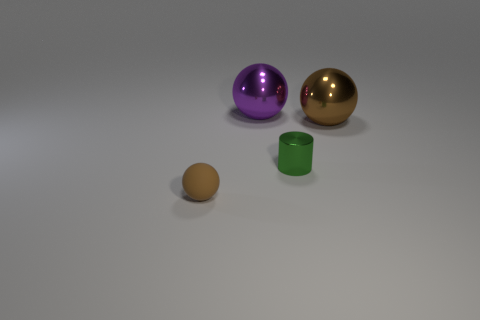Is there anything else that is the same material as the tiny ball?
Make the answer very short. No. What material is the ball that is left of the big sphere behind the brown object that is on the right side of the tiny brown sphere?
Give a very brief answer. Rubber. There is a brown sphere that is the same size as the green object; what is it made of?
Keep it short and to the point. Rubber. What is the material of the sphere that is the same color as the tiny rubber thing?
Make the answer very short. Metal. There is a large metallic object in front of the big purple metallic ball; does it have the same color as the tiny thing that is in front of the green thing?
Ensure brevity in your answer.  Yes. Are there more metal spheres that are on the left side of the big brown shiny object than big brown metal objects on the left side of the big purple metallic thing?
Offer a terse response. Yes. There is another big metallic thing that is the same shape as the brown metal thing; what color is it?
Offer a terse response. Purple. Is there any other thing that is the same shape as the small green thing?
Keep it short and to the point. No. There is a tiny green metal object; is its shape the same as the brown thing behind the small brown ball?
Provide a succinct answer. No. How many other objects are there of the same material as the purple ball?
Ensure brevity in your answer.  2. 